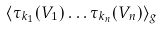<formula> <loc_0><loc_0><loc_500><loc_500>\langle \tau _ { k _ { 1 } } ( V _ { 1 } ) \dots \tau _ { k _ { n } } ( V _ { n } ) \rangle _ { g }</formula> 